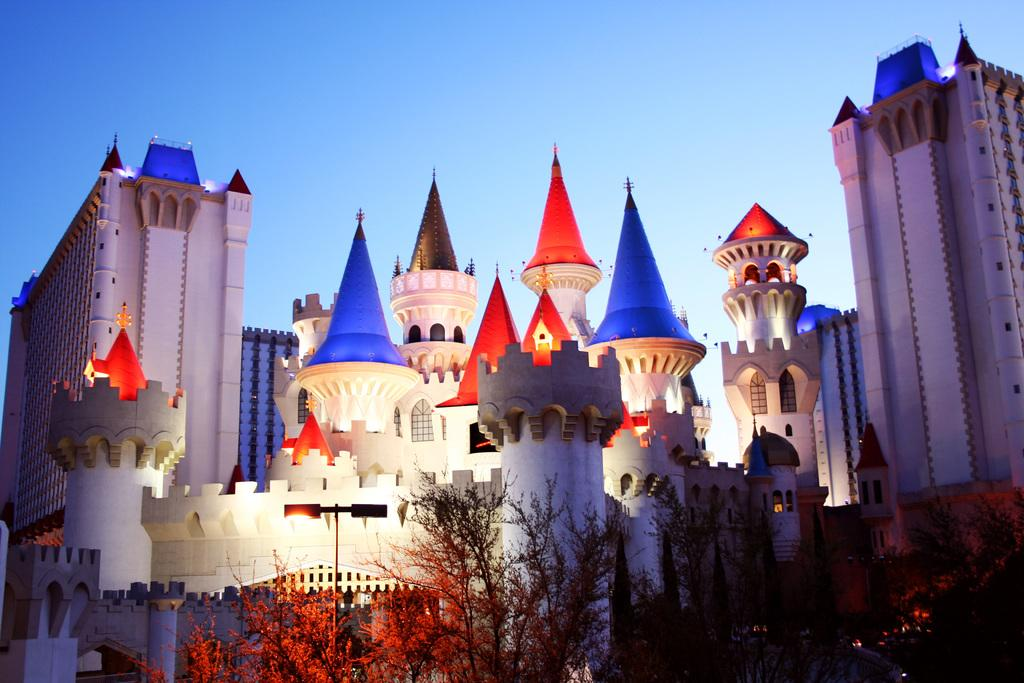What type of natural elements can be seen in the image? There are trees in the image. What type of man-made structures are present in the image? There are buildings in the image. How are the trees and buildings arranged in the image? The trees and buildings are arranged from left to right. What is the color of the sky in the image? The sky is blue in color. Can you tell me how many teeth the goose has in the image? There is no goose present in the image, so it is not possible to determine how many teeth it might have. 